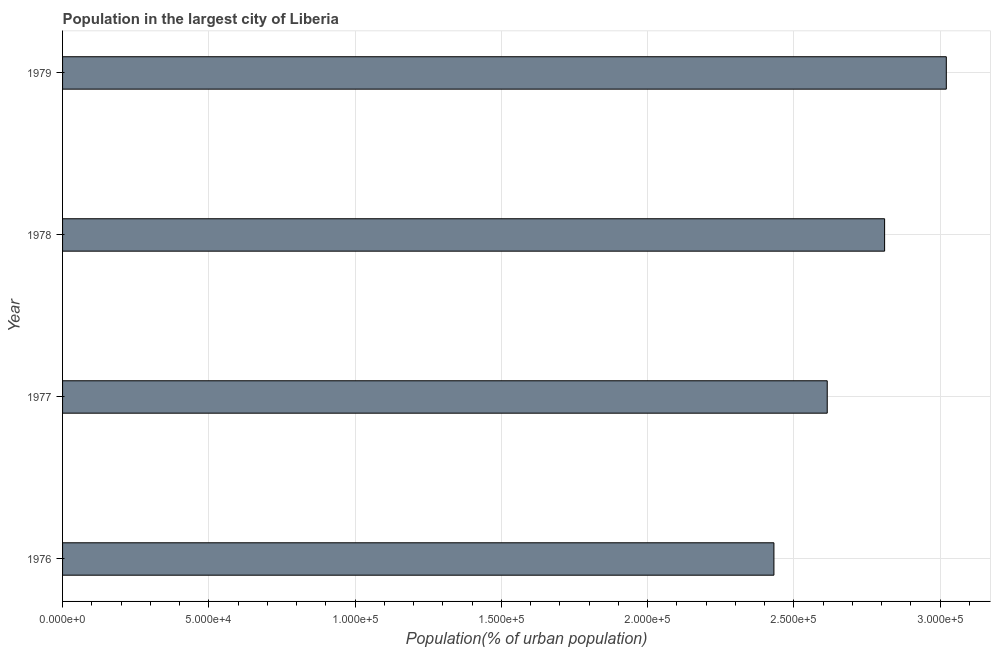Does the graph contain any zero values?
Provide a short and direct response. No. What is the title of the graph?
Offer a terse response. Population in the largest city of Liberia. What is the label or title of the X-axis?
Make the answer very short. Population(% of urban population). What is the label or title of the Y-axis?
Your answer should be compact. Year. What is the population in largest city in 1976?
Your answer should be compact. 2.43e+05. Across all years, what is the maximum population in largest city?
Offer a terse response. 3.02e+05. Across all years, what is the minimum population in largest city?
Your answer should be compact. 2.43e+05. In which year was the population in largest city maximum?
Your answer should be compact. 1979. In which year was the population in largest city minimum?
Provide a succinct answer. 1976. What is the sum of the population in largest city?
Your response must be concise. 1.09e+06. What is the difference between the population in largest city in 1976 and 1977?
Your response must be concise. -1.82e+04. What is the average population in largest city per year?
Ensure brevity in your answer.  2.72e+05. What is the median population in largest city?
Give a very brief answer. 2.71e+05. Do a majority of the years between 1977 and 1978 (inclusive) have population in largest city greater than 50000 %?
Provide a short and direct response. Yes. What is the ratio of the population in largest city in 1976 to that in 1978?
Ensure brevity in your answer.  0.86. Is the population in largest city in 1977 less than that in 1978?
Provide a succinct answer. Yes. Is the difference between the population in largest city in 1977 and 1978 greater than the difference between any two years?
Your answer should be compact. No. What is the difference between the highest and the second highest population in largest city?
Your response must be concise. 2.11e+04. Is the sum of the population in largest city in 1976 and 1979 greater than the maximum population in largest city across all years?
Provide a succinct answer. Yes. What is the difference between the highest and the lowest population in largest city?
Give a very brief answer. 5.89e+04. Are all the bars in the graph horizontal?
Keep it short and to the point. Yes. How many years are there in the graph?
Offer a terse response. 4. What is the difference between two consecutive major ticks on the X-axis?
Your response must be concise. 5.00e+04. Are the values on the major ticks of X-axis written in scientific E-notation?
Your answer should be very brief. Yes. What is the Population(% of urban population) of 1976?
Provide a short and direct response. 2.43e+05. What is the Population(% of urban population) in 1977?
Make the answer very short. 2.61e+05. What is the Population(% of urban population) of 1978?
Keep it short and to the point. 2.81e+05. What is the Population(% of urban population) in 1979?
Provide a succinct answer. 3.02e+05. What is the difference between the Population(% of urban population) in 1976 and 1977?
Your answer should be compact. -1.82e+04. What is the difference between the Population(% of urban population) in 1976 and 1978?
Offer a very short reply. -3.78e+04. What is the difference between the Population(% of urban population) in 1976 and 1979?
Make the answer very short. -5.89e+04. What is the difference between the Population(% of urban population) in 1977 and 1978?
Offer a terse response. -1.96e+04. What is the difference between the Population(% of urban population) in 1977 and 1979?
Make the answer very short. -4.07e+04. What is the difference between the Population(% of urban population) in 1978 and 1979?
Your answer should be compact. -2.11e+04. What is the ratio of the Population(% of urban population) in 1976 to that in 1978?
Make the answer very short. 0.86. What is the ratio of the Population(% of urban population) in 1976 to that in 1979?
Make the answer very short. 0.81. What is the ratio of the Population(% of urban population) in 1977 to that in 1978?
Provide a short and direct response. 0.93. What is the ratio of the Population(% of urban population) in 1977 to that in 1979?
Make the answer very short. 0.86. 